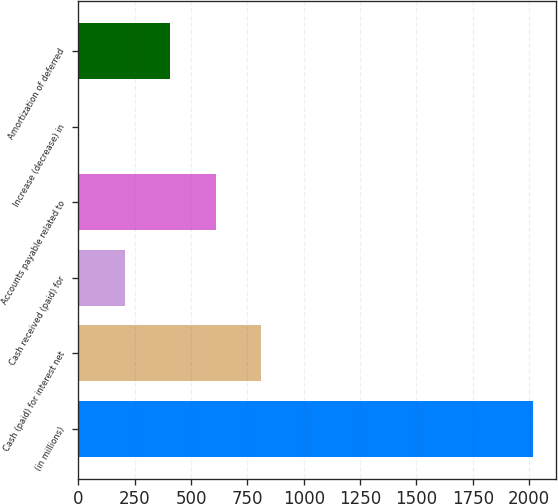Convert chart to OTSL. <chart><loc_0><loc_0><loc_500><loc_500><bar_chart><fcel>(in millions)<fcel>Cash (paid) for interest net<fcel>Cash received (paid) for<fcel>Accounts payable related to<fcel>Increase (decrease) in<fcel>Amortization of deferred<nl><fcel>2017<fcel>809.56<fcel>205.84<fcel>608.32<fcel>4.6<fcel>407.08<nl></chart> 